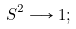Convert formula to latex. <formula><loc_0><loc_0><loc_500><loc_500>S ^ { 2 } \longrightarrow 1 ;</formula> 